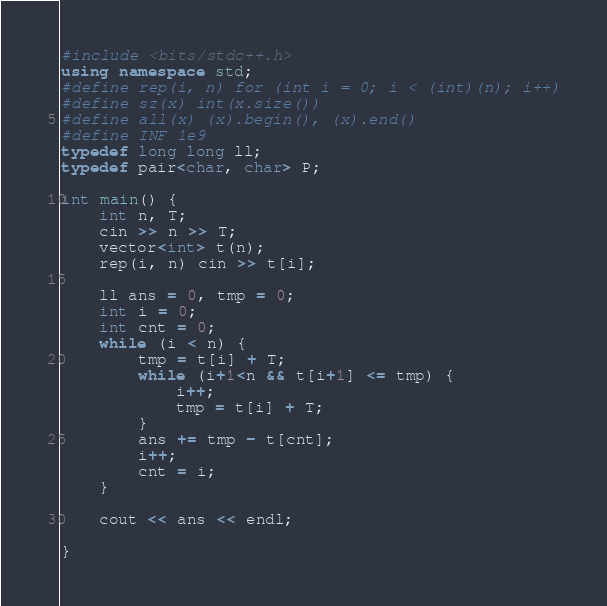<code> <loc_0><loc_0><loc_500><loc_500><_C++_>#include <bits/stdc++.h>
using namespace std;
#define rep(i, n) for (int i = 0; i < (int)(n); i++)
#define sz(x) int(x.size())
#define all(x) (x).begin(), (x).end()
#define INF 1e9
typedef long long ll;
typedef pair<char, char> P;

int main() {
    int n, T;
    cin >> n >> T;
    vector<int> t(n);
    rep(i, n) cin >> t[i];

    ll ans = 0, tmp = 0;
    int i = 0;
    int cnt = 0;
    while (i < n) {
        tmp = t[i] + T;
        while (i+1<n && t[i+1] <= tmp) {
            i++;
            tmp = t[i] + T;
        }
        ans += tmp - t[cnt];
        i++;
        cnt = i;
    }
    
    cout << ans << endl;

}</code> 